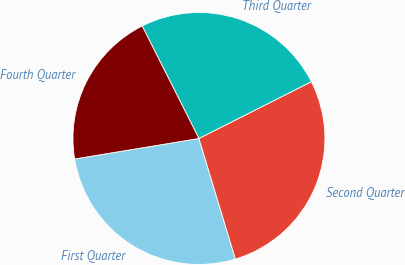<chart> <loc_0><loc_0><loc_500><loc_500><pie_chart><fcel>First Quarter<fcel>Second Quarter<fcel>Third Quarter<fcel>Fourth Quarter<nl><fcel>27.07%<fcel>27.77%<fcel>24.99%<fcel>20.16%<nl></chart> 